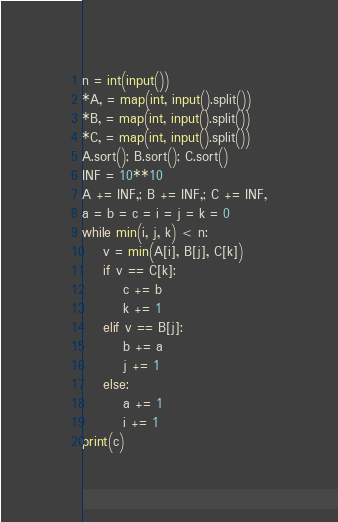<code> <loc_0><loc_0><loc_500><loc_500><_Python_>n = int(input())
*A, = map(int, input().split())
*B, = map(int, input().split())
*C, = map(int, input().split())
A.sort(); B.sort(); C.sort()
INF = 10**10
A += INF,; B += INF,; C += INF,
a = b = c = i = j = k = 0
while min(i, j, k) < n:
    v = min(A[i], B[j], C[k])
    if v == C[k]:
        c += b
        k += 1
    elif v == B[j]:
        b += a
        j += 1
    else:
        a += 1
        i += 1
print(c)</code> 